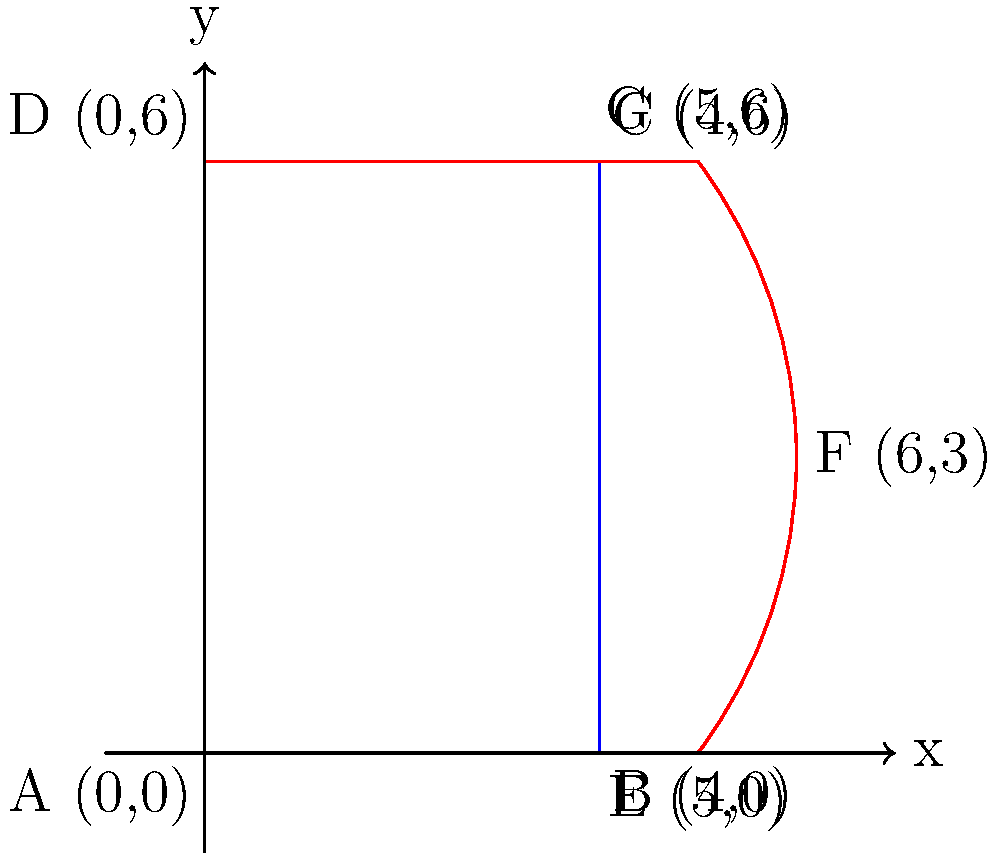In the transformation of a basic bodice block to create a new silhouette, the point B (4,0) is moved to E (5,0), and a new control point F (6,3) is introduced. If the transformation follows a quadratic Bézier curve, what are the coordinates of the control point F that would create a smooth curve from E to G? To find the coordinates of the control point F that creates a smooth quadratic Bézier curve from E to G, we can follow these steps:

1. Identify the start point E (5,0) and end point G (5,6).

2. For a smooth quadratic Bézier curve, the control point F should be equidistant from E and G along the x-axis. This means the x-coordinate of F should be:
   $$x_F = 5 + (5 - 5) / 2 = 5 + 0 / 2 = 5$$

3. The y-coordinate of F should be at the midpoint between E and G:
   $$y_F = (0 + 6) / 2 = 3$$

4. Therefore, the coordinates of the control point F should be (5,3).

5. However, in the given transformation, F is shown at (6,3), which creates a slight bulge in the curve.

6. To achieve this bulge while maintaining a smooth curve, we need to move the control point 1 unit to the right:
   $$x_F = 5 + 1 = 6$$
   $$y_F = 3$$

Thus, the coordinates of the control point F that would create the desired smooth curve from E to G are (6,3).
Answer: (6,3) 